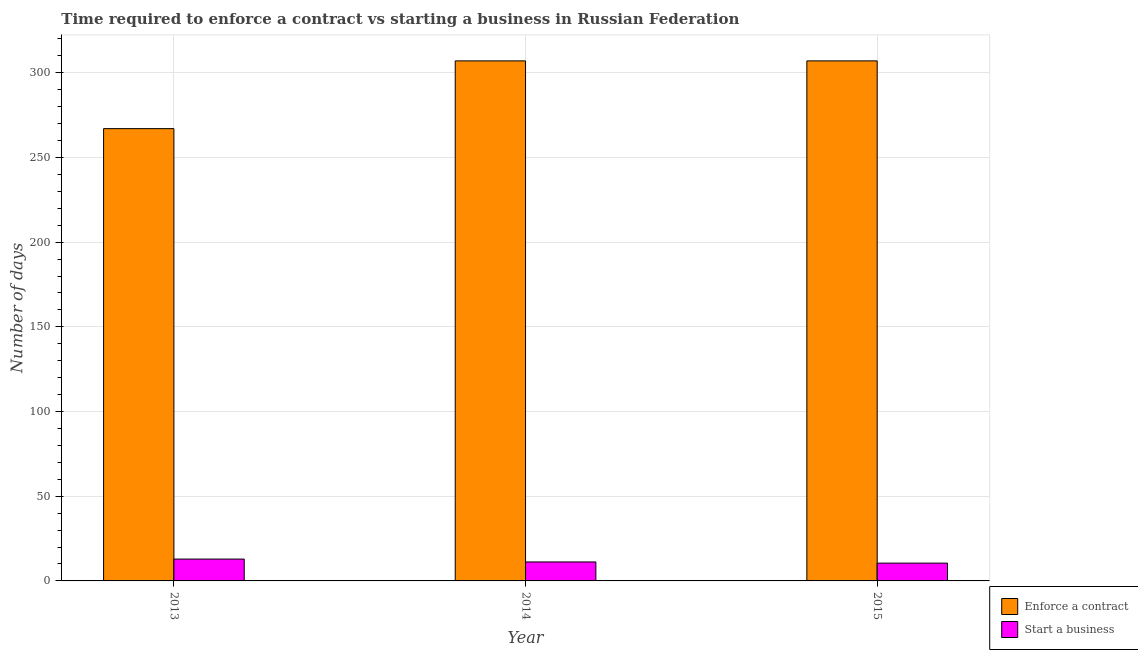How many groups of bars are there?
Make the answer very short. 3. How many bars are there on the 3rd tick from the left?
Provide a short and direct response. 2. Across all years, what is the maximum number of days to enforece a contract?
Offer a very short reply. 307. In which year was the number of days to enforece a contract minimum?
Keep it short and to the point. 2013. What is the total number of days to enforece a contract in the graph?
Provide a short and direct response. 881. What is the difference between the number of days to enforece a contract in 2014 and that in 2015?
Provide a succinct answer. 0. What is the difference between the number of days to enforece a contract in 2013 and the number of days to start a business in 2015?
Your answer should be very brief. -40. What is the average number of days to enforece a contract per year?
Provide a succinct answer. 293.67. In the year 2015, what is the difference between the number of days to enforece a contract and number of days to start a business?
Offer a very short reply. 0. In how many years, is the number of days to start a business greater than 190 days?
Provide a short and direct response. 0. What is the ratio of the number of days to start a business in 2013 to that in 2015?
Your answer should be compact. 1.23. Is the difference between the number of days to start a business in 2013 and 2014 greater than the difference between the number of days to enforece a contract in 2013 and 2014?
Provide a succinct answer. No. What is the difference between the highest and the second highest number of days to start a business?
Offer a very short reply. 1.7. What is the difference between the highest and the lowest number of days to start a business?
Offer a terse response. 2.4. Is the sum of the number of days to start a business in 2014 and 2015 greater than the maximum number of days to enforece a contract across all years?
Make the answer very short. Yes. What does the 2nd bar from the left in 2014 represents?
Ensure brevity in your answer.  Start a business. What does the 2nd bar from the right in 2015 represents?
Give a very brief answer. Enforce a contract. How many bars are there?
Give a very brief answer. 6. How many years are there in the graph?
Give a very brief answer. 3. Does the graph contain any zero values?
Your answer should be very brief. No. Where does the legend appear in the graph?
Provide a succinct answer. Bottom right. How are the legend labels stacked?
Provide a short and direct response. Vertical. What is the title of the graph?
Keep it short and to the point. Time required to enforce a contract vs starting a business in Russian Federation. What is the label or title of the X-axis?
Make the answer very short. Year. What is the label or title of the Y-axis?
Keep it short and to the point. Number of days. What is the Number of days of Enforce a contract in 2013?
Your answer should be compact. 267. What is the Number of days in Start a business in 2013?
Offer a terse response. 12.9. What is the Number of days of Enforce a contract in 2014?
Provide a short and direct response. 307. What is the Number of days in Enforce a contract in 2015?
Your response must be concise. 307. Across all years, what is the maximum Number of days of Enforce a contract?
Keep it short and to the point. 307. Across all years, what is the maximum Number of days of Start a business?
Keep it short and to the point. 12.9. Across all years, what is the minimum Number of days in Enforce a contract?
Provide a short and direct response. 267. What is the total Number of days in Enforce a contract in the graph?
Ensure brevity in your answer.  881. What is the total Number of days in Start a business in the graph?
Your answer should be compact. 34.6. What is the difference between the Number of days in Enforce a contract in 2013 and that in 2015?
Your answer should be compact. -40. What is the difference between the Number of days of Start a business in 2013 and that in 2015?
Make the answer very short. 2.4. What is the difference between the Number of days in Enforce a contract in 2014 and that in 2015?
Offer a very short reply. 0. What is the difference between the Number of days in Enforce a contract in 2013 and the Number of days in Start a business in 2014?
Provide a short and direct response. 255.8. What is the difference between the Number of days of Enforce a contract in 2013 and the Number of days of Start a business in 2015?
Ensure brevity in your answer.  256.5. What is the difference between the Number of days of Enforce a contract in 2014 and the Number of days of Start a business in 2015?
Provide a short and direct response. 296.5. What is the average Number of days in Enforce a contract per year?
Give a very brief answer. 293.67. What is the average Number of days of Start a business per year?
Your answer should be very brief. 11.53. In the year 2013, what is the difference between the Number of days of Enforce a contract and Number of days of Start a business?
Your answer should be very brief. 254.1. In the year 2014, what is the difference between the Number of days of Enforce a contract and Number of days of Start a business?
Provide a succinct answer. 295.8. In the year 2015, what is the difference between the Number of days in Enforce a contract and Number of days in Start a business?
Make the answer very short. 296.5. What is the ratio of the Number of days in Enforce a contract in 2013 to that in 2014?
Your answer should be compact. 0.87. What is the ratio of the Number of days in Start a business in 2013 to that in 2014?
Make the answer very short. 1.15. What is the ratio of the Number of days of Enforce a contract in 2013 to that in 2015?
Ensure brevity in your answer.  0.87. What is the ratio of the Number of days in Start a business in 2013 to that in 2015?
Ensure brevity in your answer.  1.23. What is the ratio of the Number of days in Enforce a contract in 2014 to that in 2015?
Keep it short and to the point. 1. What is the ratio of the Number of days of Start a business in 2014 to that in 2015?
Keep it short and to the point. 1.07. What is the difference between the highest and the second highest Number of days in Enforce a contract?
Your answer should be compact. 0. What is the difference between the highest and the second highest Number of days of Start a business?
Your response must be concise. 1.7. What is the difference between the highest and the lowest Number of days of Enforce a contract?
Offer a terse response. 40. What is the difference between the highest and the lowest Number of days of Start a business?
Ensure brevity in your answer.  2.4. 